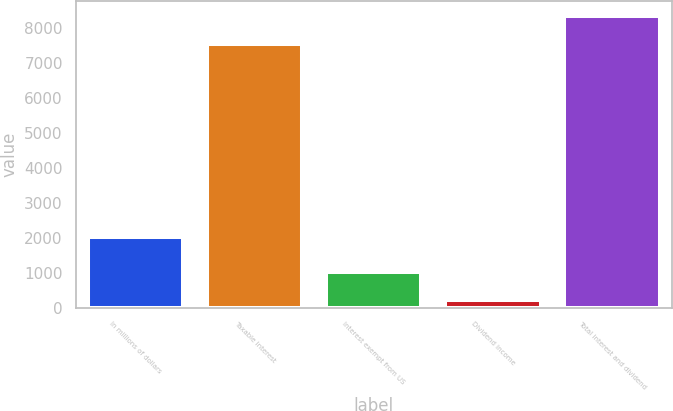Convert chart to OTSL. <chart><loc_0><loc_0><loc_500><loc_500><bar_chart><fcel>In millions of dollars<fcel>Taxable interest<fcel>Interest exempt from US<fcel>Dividend income<fcel>Total interest and dividend<nl><fcel>2017<fcel>7538<fcel>1029.3<fcel>222<fcel>8345.3<nl></chart> 